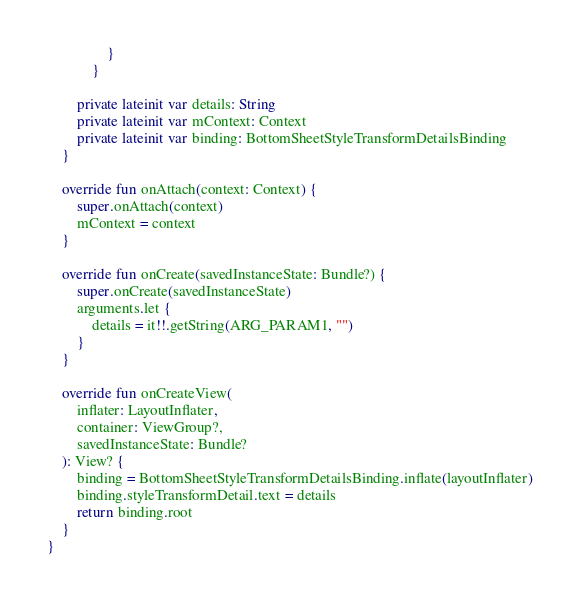<code> <loc_0><loc_0><loc_500><loc_500><_Kotlin_>                }
            }

        private lateinit var details: String
        private lateinit var mContext: Context
        private lateinit var binding: BottomSheetStyleTransformDetailsBinding
    }

    override fun onAttach(context: Context) {
        super.onAttach(context)
        mContext = context
    }

    override fun onCreate(savedInstanceState: Bundle?) {
        super.onCreate(savedInstanceState)
        arguments.let {
            details = it!!.getString(ARG_PARAM1, "")
        }
    }

    override fun onCreateView(
        inflater: LayoutInflater,
        container: ViewGroup?,
        savedInstanceState: Bundle?
    ): View? {
        binding = BottomSheetStyleTransformDetailsBinding.inflate(layoutInflater)
        binding.styleTransformDetail.text = details
        return binding.root
    }
}</code> 